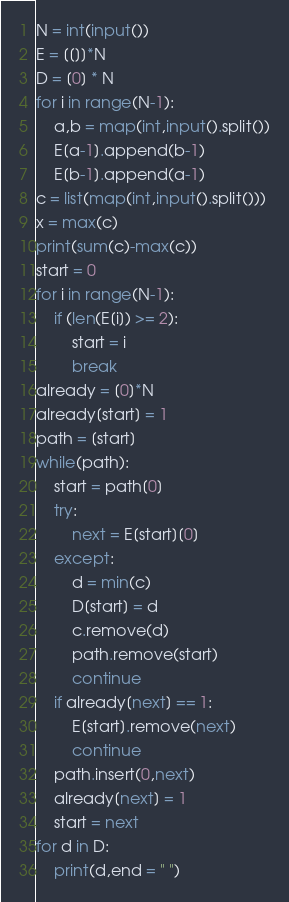<code> <loc_0><loc_0><loc_500><loc_500><_Python_>N = int(input())
E = [[]]*N
D = [0] * N
for i in range(N-1):
    a,b = map(int,input().split())
    E[a-1].append(b-1)
    E[b-1].append(a-1)
c = list(map(int,input().split()))
x = max(c)
print(sum(c)-max(c))
start = 0
for i in range(N-1):
    if (len(E[i]) >= 2):
        start = i
        break
already = [0]*N
already[start] = 1
path = [start]
while(path):
    start = path[0]
    try:
        next = E[start][0]
    except:
        d = min(c)
        D[start] = d
        c.remove(d)
        path.remove(start)
        continue
    if already[next] == 1:
        E[start].remove(next)
        continue
    path.insert(0,next)
    already[next] = 1
    start = next
for d in D:
    print(d,end = " ")</code> 